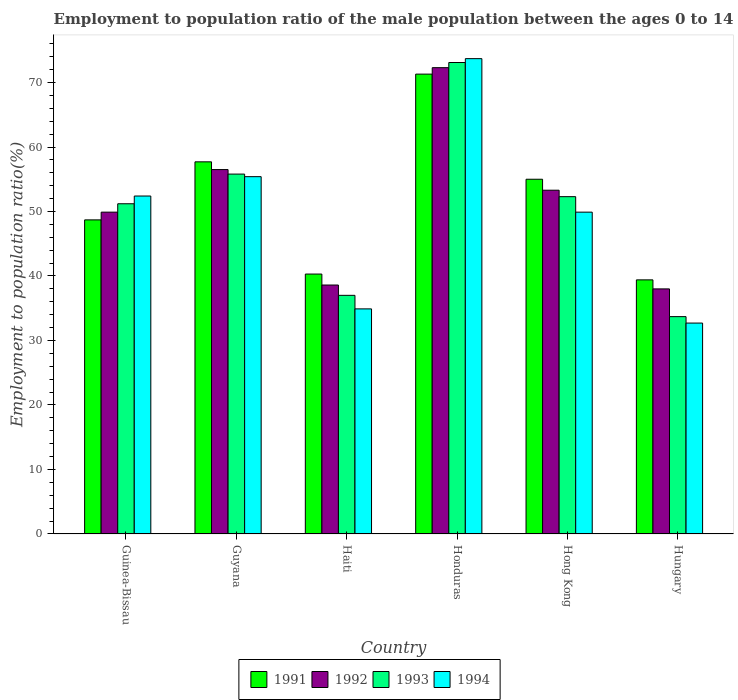How many different coloured bars are there?
Your answer should be very brief. 4. Are the number of bars per tick equal to the number of legend labels?
Provide a short and direct response. Yes. Are the number of bars on each tick of the X-axis equal?
Your answer should be compact. Yes. How many bars are there on the 5th tick from the left?
Provide a short and direct response. 4. How many bars are there on the 2nd tick from the right?
Offer a terse response. 4. What is the label of the 1st group of bars from the left?
Give a very brief answer. Guinea-Bissau. In how many cases, is the number of bars for a given country not equal to the number of legend labels?
Your response must be concise. 0. What is the employment to population ratio in 1994 in Haiti?
Offer a very short reply. 34.9. Across all countries, what is the maximum employment to population ratio in 1992?
Your answer should be compact. 72.3. Across all countries, what is the minimum employment to population ratio in 1994?
Offer a terse response. 32.7. In which country was the employment to population ratio in 1994 maximum?
Ensure brevity in your answer.  Honduras. In which country was the employment to population ratio in 1991 minimum?
Make the answer very short. Hungary. What is the total employment to population ratio in 1993 in the graph?
Provide a short and direct response. 303.1. What is the difference between the employment to population ratio in 1991 in Haiti and that in Hong Kong?
Provide a succinct answer. -14.7. What is the difference between the employment to population ratio in 1993 in Guyana and the employment to population ratio in 1992 in Haiti?
Ensure brevity in your answer.  17.2. What is the average employment to population ratio in 1992 per country?
Give a very brief answer. 51.43. What is the difference between the employment to population ratio of/in 1994 and employment to population ratio of/in 1991 in Guyana?
Offer a terse response. -2.3. In how many countries, is the employment to population ratio in 1991 greater than 70 %?
Your answer should be compact. 1. What is the ratio of the employment to population ratio in 1991 in Guinea-Bissau to that in Hong Kong?
Provide a succinct answer. 0.89. Is the employment to population ratio in 1993 in Haiti less than that in Hungary?
Keep it short and to the point. No. What is the difference between the highest and the second highest employment to population ratio in 1993?
Your response must be concise. 20.8. What is the difference between the highest and the lowest employment to population ratio in 1992?
Offer a terse response. 34.3. What does the 4th bar from the left in Honduras represents?
Your answer should be compact. 1994. What does the 3rd bar from the right in Hong Kong represents?
Your response must be concise. 1992. How many bars are there?
Your answer should be very brief. 24. Are all the bars in the graph horizontal?
Offer a terse response. No. What is the difference between two consecutive major ticks on the Y-axis?
Ensure brevity in your answer.  10. How many legend labels are there?
Provide a succinct answer. 4. What is the title of the graph?
Provide a succinct answer. Employment to population ratio of the male population between the ages 0 to 14. What is the label or title of the Y-axis?
Your response must be concise. Employment to population ratio(%). What is the Employment to population ratio(%) of 1991 in Guinea-Bissau?
Give a very brief answer. 48.7. What is the Employment to population ratio(%) of 1992 in Guinea-Bissau?
Offer a very short reply. 49.9. What is the Employment to population ratio(%) in 1993 in Guinea-Bissau?
Your answer should be compact. 51.2. What is the Employment to population ratio(%) in 1994 in Guinea-Bissau?
Make the answer very short. 52.4. What is the Employment to population ratio(%) of 1991 in Guyana?
Your answer should be compact. 57.7. What is the Employment to population ratio(%) in 1992 in Guyana?
Your response must be concise. 56.5. What is the Employment to population ratio(%) in 1993 in Guyana?
Your answer should be very brief. 55.8. What is the Employment to population ratio(%) of 1994 in Guyana?
Your response must be concise. 55.4. What is the Employment to population ratio(%) in 1991 in Haiti?
Your response must be concise. 40.3. What is the Employment to population ratio(%) in 1992 in Haiti?
Make the answer very short. 38.6. What is the Employment to population ratio(%) of 1994 in Haiti?
Keep it short and to the point. 34.9. What is the Employment to population ratio(%) in 1991 in Honduras?
Offer a terse response. 71.3. What is the Employment to population ratio(%) in 1992 in Honduras?
Provide a succinct answer. 72.3. What is the Employment to population ratio(%) in 1993 in Honduras?
Give a very brief answer. 73.1. What is the Employment to population ratio(%) of 1994 in Honduras?
Your response must be concise. 73.7. What is the Employment to population ratio(%) of 1992 in Hong Kong?
Provide a succinct answer. 53.3. What is the Employment to population ratio(%) in 1993 in Hong Kong?
Give a very brief answer. 52.3. What is the Employment to population ratio(%) in 1994 in Hong Kong?
Your answer should be very brief. 49.9. What is the Employment to population ratio(%) in 1991 in Hungary?
Keep it short and to the point. 39.4. What is the Employment to population ratio(%) in 1993 in Hungary?
Keep it short and to the point. 33.7. What is the Employment to population ratio(%) in 1994 in Hungary?
Offer a very short reply. 32.7. Across all countries, what is the maximum Employment to population ratio(%) in 1991?
Your answer should be very brief. 71.3. Across all countries, what is the maximum Employment to population ratio(%) of 1992?
Give a very brief answer. 72.3. Across all countries, what is the maximum Employment to population ratio(%) of 1993?
Your answer should be compact. 73.1. Across all countries, what is the maximum Employment to population ratio(%) in 1994?
Give a very brief answer. 73.7. Across all countries, what is the minimum Employment to population ratio(%) of 1991?
Ensure brevity in your answer.  39.4. Across all countries, what is the minimum Employment to population ratio(%) of 1992?
Make the answer very short. 38. Across all countries, what is the minimum Employment to population ratio(%) in 1993?
Your response must be concise. 33.7. Across all countries, what is the minimum Employment to population ratio(%) of 1994?
Ensure brevity in your answer.  32.7. What is the total Employment to population ratio(%) in 1991 in the graph?
Your response must be concise. 312.4. What is the total Employment to population ratio(%) in 1992 in the graph?
Offer a terse response. 308.6. What is the total Employment to population ratio(%) in 1993 in the graph?
Your response must be concise. 303.1. What is the total Employment to population ratio(%) in 1994 in the graph?
Your response must be concise. 299. What is the difference between the Employment to population ratio(%) of 1991 in Guinea-Bissau and that in Guyana?
Offer a terse response. -9. What is the difference between the Employment to population ratio(%) of 1992 in Guinea-Bissau and that in Guyana?
Give a very brief answer. -6.6. What is the difference between the Employment to population ratio(%) in 1993 in Guinea-Bissau and that in Haiti?
Offer a very short reply. 14.2. What is the difference between the Employment to population ratio(%) of 1994 in Guinea-Bissau and that in Haiti?
Make the answer very short. 17.5. What is the difference between the Employment to population ratio(%) of 1991 in Guinea-Bissau and that in Honduras?
Provide a short and direct response. -22.6. What is the difference between the Employment to population ratio(%) in 1992 in Guinea-Bissau and that in Honduras?
Offer a very short reply. -22.4. What is the difference between the Employment to population ratio(%) in 1993 in Guinea-Bissau and that in Honduras?
Ensure brevity in your answer.  -21.9. What is the difference between the Employment to population ratio(%) of 1994 in Guinea-Bissau and that in Honduras?
Provide a succinct answer. -21.3. What is the difference between the Employment to population ratio(%) of 1991 in Guinea-Bissau and that in Hong Kong?
Ensure brevity in your answer.  -6.3. What is the difference between the Employment to population ratio(%) in 1993 in Guinea-Bissau and that in Hong Kong?
Offer a terse response. -1.1. What is the difference between the Employment to population ratio(%) in 1991 in Guinea-Bissau and that in Hungary?
Make the answer very short. 9.3. What is the difference between the Employment to population ratio(%) of 1992 in Guinea-Bissau and that in Hungary?
Offer a terse response. 11.9. What is the difference between the Employment to population ratio(%) of 1994 in Guinea-Bissau and that in Hungary?
Ensure brevity in your answer.  19.7. What is the difference between the Employment to population ratio(%) of 1991 in Guyana and that in Haiti?
Your answer should be compact. 17.4. What is the difference between the Employment to population ratio(%) of 1993 in Guyana and that in Haiti?
Ensure brevity in your answer.  18.8. What is the difference between the Employment to population ratio(%) of 1994 in Guyana and that in Haiti?
Your response must be concise. 20.5. What is the difference between the Employment to population ratio(%) of 1992 in Guyana and that in Honduras?
Give a very brief answer. -15.8. What is the difference between the Employment to population ratio(%) in 1993 in Guyana and that in Honduras?
Offer a terse response. -17.3. What is the difference between the Employment to population ratio(%) in 1994 in Guyana and that in Honduras?
Provide a short and direct response. -18.3. What is the difference between the Employment to population ratio(%) of 1993 in Guyana and that in Hong Kong?
Your response must be concise. 3.5. What is the difference between the Employment to population ratio(%) of 1993 in Guyana and that in Hungary?
Provide a short and direct response. 22.1. What is the difference between the Employment to population ratio(%) in 1994 in Guyana and that in Hungary?
Keep it short and to the point. 22.7. What is the difference between the Employment to population ratio(%) in 1991 in Haiti and that in Honduras?
Your answer should be compact. -31. What is the difference between the Employment to population ratio(%) of 1992 in Haiti and that in Honduras?
Keep it short and to the point. -33.7. What is the difference between the Employment to population ratio(%) in 1993 in Haiti and that in Honduras?
Your answer should be very brief. -36.1. What is the difference between the Employment to population ratio(%) in 1994 in Haiti and that in Honduras?
Provide a short and direct response. -38.8. What is the difference between the Employment to population ratio(%) of 1991 in Haiti and that in Hong Kong?
Give a very brief answer. -14.7. What is the difference between the Employment to population ratio(%) of 1992 in Haiti and that in Hong Kong?
Offer a very short reply. -14.7. What is the difference between the Employment to population ratio(%) in 1993 in Haiti and that in Hong Kong?
Offer a very short reply. -15.3. What is the difference between the Employment to population ratio(%) of 1992 in Haiti and that in Hungary?
Give a very brief answer. 0.6. What is the difference between the Employment to population ratio(%) in 1991 in Honduras and that in Hong Kong?
Your answer should be very brief. 16.3. What is the difference between the Employment to population ratio(%) of 1992 in Honduras and that in Hong Kong?
Offer a terse response. 19. What is the difference between the Employment to population ratio(%) in 1993 in Honduras and that in Hong Kong?
Offer a very short reply. 20.8. What is the difference between the Employment to population ratio(%) in 1994 in Honduras and that in Hong Kong?
Make the answer very short. 23.8. What is the difference between the Employment to population ratio(%) of 1991 in Honduras and that in Hungary?
Offer a very short reply. 31.9. What is the difference between the Employment to population ratio(%) in 1992 in Honduras and that in Hungary?
Ensure brevity in your answer.  34.3. What is the difference between the Employment to population ratio(%) of 1993 in Honduras and that in Hungary?
Ensure brevity in your answer.  39.4. What is the difference between the Employment to population ratio(%) in 1993 in Hong Kong and that in Hungary?
Keep it short and to the point. 18.6. What is the difference between the Employment to population ratio(%) of 1991 in Guinea-Bissau and the Employment to population ratio(%) of 1993 in Guyana?
Give a very brief answer. -7.1. What is the difference between the Employment to population ratio(%) of 1992 in Guinea-Bissau and the Employment to population ratio(%) of 1993 in Guyana?
Provide a short and direct response. -5.9. What is the difference between the Employment to population ratio(%) of 1991 in Guinea-Bissau and the Employment to population ratio(%) of 1994 in Haiti?
Give a very brief answer. 13.8. What is the difference between the Employment to population ratio(%) of 1991 in Guinea-Bissau and the Employment to population ratio(%) of 1992 in Honduras?
Ensure brevity in your answer.  -23.6. What is the difference between the Employment to population ratio(%) in 1991 in Guinea-Bissau and the Employment to population ratio(%) in 1993 in Honduras?
Give a very brief answer. -24.4. What is the difference between the Employment to population ratio(%) of 1992 in Guinea-Bissau and the Employment to population ratio(%) of 1993 in Honduras?
Your response must be concise. -23.2. What is the difference between the Employment to population ratio(%) of 1992 in Guinea-Bissau and the Employment to population ratio(%) of 1994 in Honduras?
Offer a very short reply. -23.8. What is the difference between the Employment to population ratio(%) of 1993 in Guinea-Bissau and the Employment to population ratio(%) of 1994 in Honduras?
Provide a succinct answer. -22.5. What is the difference between the Employment to population ratio(%) in 1991 in Guinea-Bissau and the Employment to population ratio(%) in 1993 in Hong Kong?
Provide a succinct answer. -3.6. What is the difference between the Employment to population ratio(%) of 1992 in Guinea-Bissau and the Employment to population ratio(%) of 1994 in Hong Kong?
Offer a terse response. 0. What is the difference between the Employment to population ratio(%) in 1993 in Guinea-Bissau and the Employment to population ratio(%) in 1994 in Hong Kong?
Offer a very short reply. 1.3. What is the difference between the Employment to population ratio(%) in 1991 in Guinea-Bissau and the Employment to population ratio(%) in 1994 in Hungary?
Provide a succinct answer. 16. What is the difference between the Employment to population ratio(%) in 1992 in Guinea-Bissau and the Employment to population ratio(%) in 1993 in Hungary?
Your response must be concise. 16.2. What is the difference between the Employment to population ratio(%) in 1993 in Guinea-Bissau and the Employment to population ratio(%) in 1994 in Hungary?
Provide a short and direct response. 18.5. What is the difference between the Employment to population ratio(%) in 1991 in Guyana and the Employment to population ratio(%) in 1993 in Haiti?
Offer a terse response. 20.7. What is the difference between the Employment to population ratio(%) in 1991 in Guyana and the Employment to population ratio(%) in 1994 in Haiti?
Give a very brief answer. 22.8. What is the difference between the Employment to population ratio(%) in 1992 in Guyana and the Employment to population ratio(%) in 1994 in Haiti?
Give a very brief answer. 21.6. What is the difference between the Employment to population ratio(%) of 1993 in Guyana and the Employment to population ratio(%) of 1994 in Haiti?
Your answer should be compact. 20.9. What is the difference between the Employment to population ratio(%) of 1991 in Guyana and the Employment to population ratio(%) of 1992 in Honduras?
Your answer should be very brief. -14.6. What is the difference between the Employment to population ratio(%) in 1991 in Guyana and the Employment to population ratio(%) in 1993 in Honduras?
Your response must be concise. -15.4. What is the difference between the Employment to population ratio(%) of 1992 in Guyana and the Employment to population ratio(%) of 1993 in Honduras?
Offer a terse response. -16.6. What is the difference between the Employment to population ratio(%) in 1992 in Guyana and the Employment to population ratio(%) in 1994 in Honduras?
Give a very brief answer. -17.2. What is the difference between the Employment to population ratio(%) of 1993 in Guyana and the Employment to population ratio(%) of 1994 in Honduras?
Provide a short and direct response. -17.9. What is the difference between the Employment to population ratio(%) of 1991 in Guyana and the Employment to population ratio(%) of 1994 in Hong Kong?
Make the answer very short. 7.8. What is the difference between the Employment to population ratio(%) in 1992 in Guyana and the Employment to population ratio(%) in 1993 in Hong Kong?
Make the answer very short. 4.2. What is the difference between the Employment to population ratio(%) in 1991 in Guyana and the Employment to population ratio(%) in 1993 in Hungary?
Ensure brevity in your answer.  24. What is the difference between the Employment to population ratio(%) in 1991 in Guyana and the Employment to population ratio(%) in 1994 in Hungary?
Your response must be concise. 25. What is the difference between the Employment to population ratio(%) in 1992 in Guyana and the Employment to population ratio(%) in 1993 in Hungary?
Offer a very short reply. 22.8. What is the difference between the Employment to population ratio(%) in 1992 in Guyana and the Employment to population ratio(%) in 1994 in Hungary?
Your answer should be compact. 23.8. What is the difference between the Employment to population ratio(%) of 1993 in Guyana and the Employment to population ratio(%) of 1994 in Hungary?
Your response must be concise. 23.1. What is the difference between the Employment to population ratio(%) of 1991 in Haiti and the Employment to population ratio(%) of 1992 in Honduras?
Your answer should be very brief. -32. What is the difference between the Employment to population ratio(%) of 1991 in Haiti and the Employment to population ratio(%) of 1993 in Honduras?
Keep it short and to the point. -32.8. What is the difference between the Employment to population ratio(%) of 1991 in Haiti and the Employment to population ratio(%) of 1994 in Honduras?
Provide a short and direct response. -33.4. What is the difference between the Employment to population ratio(%) in 1992 in Haiti and the Employment to population ratio(%) in 1993 in Honduras?
Ensure brevity in your answer.  -34.5. What is the difference between the Employment to population ratio(%) of 1992 in Haiti and the Employment to population ratio(%) of 1994 in Honduras?
Your answer should be compact. -35.1. What is the difference between the Employment to population ratio(%) in 1993 in Haiti and the Employment to population ratio(%) in 1994 in Honduras?
Your answer should be very brief. -36.7. What is the difference between the Employment to population ratio(%) in 1992 in Haiti and the Employment to population ratio(%) in 1993 in Hong Kong?
Make the answer very short. -13.7. What is the difference between the Employment to population ratio(%) of 1992 in Haiti and the Employment to population ratio(%) of 1994 in Hong Kong?
Make the answer very short. -11.3. What is the difference between the Employment to population ratio(%) of 1993 in Haiti and the Employment to population ratio(%) of 1994 in Hong Kong?
Your answer should be compact. -12.9. What is the difference between the Employment to population ratio(%) in 1991 in Haiti and the Employment to population ratio(%) in 1992 in Hungary?
Give a very brief answer. 2.3. What is the difference between the Employment to population ratio(%) in 1991 in Haiti and the Employment to population ratio(%) in 1993 in Hungary?
Make the answer very short. 6.6. What is the difference between the Employment to population ratio(%) of 1991 in Haiti and the Employment to population ratio(%) of 1994 in Hungary?
Keep it short and to the point. 7.6. What is the difference between the Employment to population ratio(%) in 1993 in Haiti and the Employment to population ratio(%) in 1994 in Hungary?
Offer a terse response. 4.3. What is the difference between the Employment to population ratio(%) of 1991 in Honduras and the Employment to population ratio(%) of 1992 in Hong Kong?
Your response must be concise. 18. What is the difference between the Employment to population ratio(%) in 1991 in Honduras and the Employment to population ratio(%) in 1993 in Hong Kong?
Keep it short and to the point. 19. What is the difference between the Employment to population ratio(%) of 1991 in Honduras and the Employment to population ratio(%) of 1994 in Hong Kong?
Offer a very short reply. 21.4. What is the difference between the Employment to population ratio(%) of 1992 in Honduras and the Employment to population ratio(%) of 1993 in Hong Kong?
Provide a short and direct response. 20. What is the difference between the Employment to population ratio(%) in 1992 in Honduras and the Employment to population ratio(%) in 1994 in Hong Kong?
Make the answer very short. 22.4. What is the difference between the Employment to population ratio(%) of 1993 in Honduras and the Employment to population ratio(%) of 1994 in Hong Kong?
Make the answer very short. 23.2. What is the difference between the Employment to population ratio(%) of 1991 in Honduras and the Employment to population ratio(%) of 1992 in Hungary?
Provide a short and direct response. 33.3. What is the difference between the Employment to population ratio(%) in 1991 in Honduras and the Employment to population ratio(%) in 1993 in Hungary?
Offer a terse response. 37.6. What is the difference between the Employment to population ratio(%) in 1991 in Honduras and the Employment to population ratio(%) in 1994 in Hungary?
Keep it short and to the point. 38.6. What is the difference between the Employment to population ratio(%) in 1992 in Honduras and the Employment to population ratio(%) in 1993 in Hungary?
Provide a succinct answer. 38.6. What is the difference between the Employment to population ratio(%) of 1992 in Honduras and the Employment to population ratio(%) of 1994 in Hungary?
Your answer should be compact. 39.6. What is the difference between the Employment to population ratio(%) of 1993 in Honduras and the Employment to population ratio(%) of 1994 in Hungary?
Provide a short and direct response. 40.4. What is the difference between the Employment to population ratio(%) of 1991 in Hong Kong and the Employment to population ratio(%) of 1993 in Hungary?
Make the answer very short. 21.3. What is the difference between the Employment to population ratio(%) in 1991 in Hong Kong and the Employment to population ratio(%) in 1994 in Hungary?
Provide a short and direct response. 22.3. What is the difference between the Employment to population ratio(%) in 1992 in Hong Kong and the Employment to population ratio(%) in 1993 in Hungary?
Your response must be concise. 19.6. What is the difference between the Employment to population ratio(%) of 1992 in Hong Kong and the Employment to population ratio(%) of 1994 in Hungary?
Offer a very short reply. 20.6. What is the difference between the Employment to population ratio(%) of 1993 in Hong Kong and the Employment to population ratio(%) of 1994 in Hungary?
Give a very brief answer. 19.6. What is the average Employment to population ratio(%) in 1991 per country?
Offer a very short reply. 52.07. What is the average Employment to population ratio(%) of 1992 per country?
Make the answer very short. 51.43. What is the average Employment to population ratio(%) of 1993 per country?
Make the answer very short. 50.52. What is the average Employment to population ratio(%) in 1994 per country?
Make the answer very short. 49.83. What is the difference between the Employment to population ratio(%) of 1991 and Employment to population ratio(%) of 1994 in Guinea-Bissau?
Make the answer very short. -3.7. What is the difference between the Employment to population ratio(%) in 1991 and Employment to population ratio(%) in 1994 in Guyana?
Provide a succinct answer. 2.3. What is the difference between the Employment to population ratio(%) of 1991 and Employment to population ratio(%) of 1993 in Haiti?
Offer a terse response. 3.3. What is the difference between the Employment to population ratio(%) of 1991 and Employment to population ratio(%) of 1994 in Haiti?
Your answer should be very brief. 5.4. What is the difference between the Employment to population ratio(%) of 1992 and Employment to population ratio(%) of 1994 in Haiti?
Offer a terse response. 3.7. What is the difference between the Employment to population ratio(%) of 1991 and Employment to population ratio(%) of 1992 in Honduras?
Ensure brevity in your answer.  -1. What is the difference between the Employment to population ratio(%) in 1991 and Employment to population ratio(%) in 1993 in Honduras?
Offer a terse response. -1.8. What is the difference between the Employment to population ratio(%) in 1991 and Employment to population ratio(%) in 1994 in Honduras?
Offer a very short reply. -2.4. What is the difference between the Employment to population ratio(%) of 1992 and Employment to population ratio(%) of 1993 in Honduras?
Your answer should be very brief. -0.8. What is the difference between the Employment to population ratio(%) of 1992 and Employment to population ratio(%) of 1993 in Hong Kong?
Offer a very short reply. 1. What is the difference between the Employment to population ratio(%) in 1991 and Employment to population ratio(%) in 1992 in Hungary?
Provide a succinct answer. 1.4. What is the difference between the Employment to population ratio(%) of 1992 and Employment to population ratio(%) of 1994 in Hungary?
Your response must be concise. 5.3. What is the ratio of the Employment to population ratio(%) in 1991 in Guinea-Bissau to that in Guyana?
Offer a terse response. 0.84. What is the ratio of the Employment to population ratio(%) of 1992 in Guinea-Bissau to that in Guyana?
Your response must be concise. 0.88. What is the ratio of the Employment to population ratio(%) of 1993 in Guinea-Bissau to that in Guyana?
Give a very brief answer. 0.92. What is the ratio of the Employment to population ratio(%) of 1994 in Guinea-Bissau to that in Guyana?
Provide a short and direct response. 0.95. What is the ratio of the Employment to population ratio(%) in 1991 in Guinea-Bissau to that in Haiti?
Keep it short and to the point. 1.21. What is the ratio of the Employment to population ratio(%) in 1992 in Guinea-Bissau to that in Haiti?
Ensure brevity in your answer.  1.29. What is the ratio of the Employment to population ratio(%) in 1993 in Guinea-Bissau to that in Haiti?
Offer a terse response. 1.38. What is the ratio of the Employment to population ratio(%) of 1994 in Guinea-Bissau to that in Haiti?
Make the answer very short. 1.5. What is the ratio of the Employment to population ratio(%) in 1991 in Guinea-Bissau to that in Honduras?
Offer a very short reply. 0.68. What is the ratio of the Employment to population ratio(%) of 1992 in Guinea-Bissau to that in Honduras?
Your response must be concise. 0.69. What is the ratio of the Employment to population ratio(%) in 1993 in Guinea-Bissau to that in Honduras?
Your answer should be compact. 0.7. What is the ratio of the Employment to population ratio(%) in 1994 in Guinea-Bissau to that in Honduras?
Ensure brevity in your answer.  0.71. What is the ratio of the Employment to population ratio(%) of 1991 in Guinea-Bissau to that in Hong Kong?
Offer a terse response. 0.89. What is the ratio of the Employment to population ratio(%) of 1992 in Guinea-Bissau to that in Hong Kong?
Your answer should be compact. 0.94. What is the ratio of the Employment to population ratio(%) of 1993 in Guinea-Bissau to that in Hong Kong?
Offer a terse response. 0.98. What is the ratio of the Employment to population ratio(%) in 1994 in Guinea-Bissau to that in Hong Kong?
Provide a succinct answer. 1.05. What is the ratio of the Employment to population ratio(%) in 1991 in Guinea-Bissau to that in Hungary?
Offer a terse response. 1.24. What is the ratio of the Employment to population ratio(%) of 1992 in Guinea-Bissau to that in Hungary?
Your answer should be very brief. 1.31. What is the ratio of the Employment to population ratio(%) of 1993 in Guinea-Bissau to that in Hungary?
Ensure brevity in your answer.  1.52. What is the ratio of the Employment to population ratio(%) of 1994 in Guinea-Bissau to that in Hungary?
Ensure brevity in your answer.  1.6. What is the ratio of the Employment to population ratio(%) in 1991 in Guyana to that in Haiti?
Your answer should be very brief. 1.43. What is the ratio of the Employment to population ratio(%) in 1992 in Guyana to that in Haiti?
Provide a short and direct response. 1.46. What is the ratio of the Employment to population ratio(%) in 1993 in Guyana to that in Haiti?
Give a very brief answer. 1.51. What is the ratio of the Employment to population ratio(%) in 1994 in Guyana to that in Haiti?
Provide a succinct answer. 1.59. What is the ratio of the Employment to population ratio(%) of 1991 in Guyana to that in Honduras?
Your answer should be very brief. 0.81. What is the ratio of the Employment to population ratio(%) of 1992 in Guyana to that in Honduras?
Your answer should be very brief. 0.78. What is the ratio of the Employment to population ratio(%) of 1993 in Guyana to that in Honduras?
Ensure brevity in your answer.  0.76. What is the ratio of the Employment to population ratio(%) in 1994 in Guyana to that in Honduras?
Your response must be concise. 0.75. What is the ratio of the Employment to population ratio(%) of 1991 in Guyana to that in Hong Kong?
Your response must be concise. 1.05. What is the ratio of the Employment to population ratio(%) of 1992 in Guyana to that in Hong Kong?
Provide a succinct answer. 1.06. What is the ratio of the Employment to population ratio(%) in 1993 in Guyana to that in Hong Kong?
Offer a terse response. 1.07. What is the ratio of the Employment to population ratio(%) in 1994 in Guyana to that in Hong Kong?
Offer a very short reply. 1.11. What is the ratio of the Employment to population ratio(%) of 1991 in Guyana to that in Hungary?
Ensure brevity in your answer.  1.46. What is the ratio of the Employment to population ratio(%) of 1992 in Guyana to that in Hungary?
Your answer should be compact. 1.49. What is the ratio of the Employment to population ratio(%) in 1993 in Guyana to that in Hungary?
Provide a short and direct response. 1.66. What is the ratio of the Employment to population ratio(%) in 1994 in Guyana to that in Hungary?
Your answer should be compact. 1.69. What is the ratio of the Employment to population ratio(%) of 1991 in Haiti to that in Honduras?
Provide a succinct answer. 0.57. What is the ratio of the Employment to population ratio(%) in 1992 in Haiti to that in Honduras?
Make the answer very short. 0.53. What is the ratio of the Employment to population ratio(%) in 1993 in Haiti to that in Honduras?
Offer a terse response. 0.51. What is the ratio of the Employment to population ratio(%) in 1994 in Haiti to that in Honduras?
Your response must be concise. 0.47. What is the ratio of the Employment to population ratio(%) of 1991 in Haiti to that in Hong Kong?
Offer a terse response. 0.73. What is the ratio of the Employment to population ratio(%) in 1992 in Haiti to that in Hong Kong?
Ensure brevity in your answer.  0.72. What is the ratio of the Employment to population ratio(%) of 1993 in Haiti to that in Hong Kong?
Provide a succinct answer. 0.71. What is the ratio of the Employment to population ratio(%) in 1994 in Haiti to that in Hong Kong?
Provide a succinct answer. 0.7. What is the ratio of the Employment to population ratio(%) of 1991 in Haiti to that in Hungary?
Ensure brevity in your answer.  1.02. What is the ratio of the Employment to population ratio(%) in 1992 in Haiti to that in Hungary?
Your response must be concise. 1.02. What is the ratio of the Employment to population ratio(%) of 1993 in Haiti to that in Hungary?
Give a very brief answer. 1.1. What is the ratio of the Employment to population ratio(%) of 1994 in Haiti to that in Hungary?
Your response must be concise. 1.07. What is the ratio of the Employment to population ratio(%) in 1991 in Honduras to that in Hong Kong?
Your answer should be very brief. 1.3. What is the ratio of the Employment to population ratio(%) in 1992 in Honduras to that in Hong Kong?
Offer a very short reply. 1.36. What is the ratio of the Employment to population ratio(%) in 1993 in Honduras to that in Hong Kong?
Ensure brevity in your answer.  1.4. What is the ratio of the Employment to population ratio(%) of 1994 in Honduras to that in Hong Kong?
Offer a very short reply. 1.48. What is the ratio of the Employment to population ratio(%) of 1991 in Honduras to that in Hungary?
Offer a terse response. 1.81. What is the ratio of the Employment to population ratio(%) of 1992 in Honduras to that in Hungary?
Your answer should be compact. 1.9. What is the ratio of the Employment to population ratio(%) of 1993 in Honduras to that in Hungary?
Your answer should be very brief. 2.17. What is the ratio of the Employment to population ratio(%) in 1994 in Honduras to that in Hungary?
Ensure brevity in your answer.  2.25. What is the ratio of the Employment to population ratio(%) of 1991 in Hong Kong to that in Hungary?
Your answer should be compact. 1.4. What is the ratio of the Employment to population ratio(%) of 1992 in Hong Kong to that in Hungary?
Your response must be concise. 1.4. What is the ratio of the Employment to population ratio(%) of 1993 in Hong Kong to that in Hungary?
Provide a short and direct response. 1.55. What is the ratio of the Employment to population ratio(%) of 1994 in Hong Kong to that in Hungary?
Offer a terse response. 1.53. What is the difference between the highest and the second highest Employment to population ratio(%) in 1994?
Ensure brevity in your answer.  18.3. What is the difference between the highest and the lowest Employment to population ratio(%) of 1991?
Keep it short and to the point. 31.9. What is the difference between the highest and the lowest Employment to population ratio(%) in 1992?
Offer a very short reply. 34.3. What is the difference between the highest and the lowest Employment to population ratio(%) in 1993?
Offer a very short reply. 39.4. What is the difference between the highest and the lowest Employment to population ratio(%) of 1994?
Your answer should be very brief. 41. 